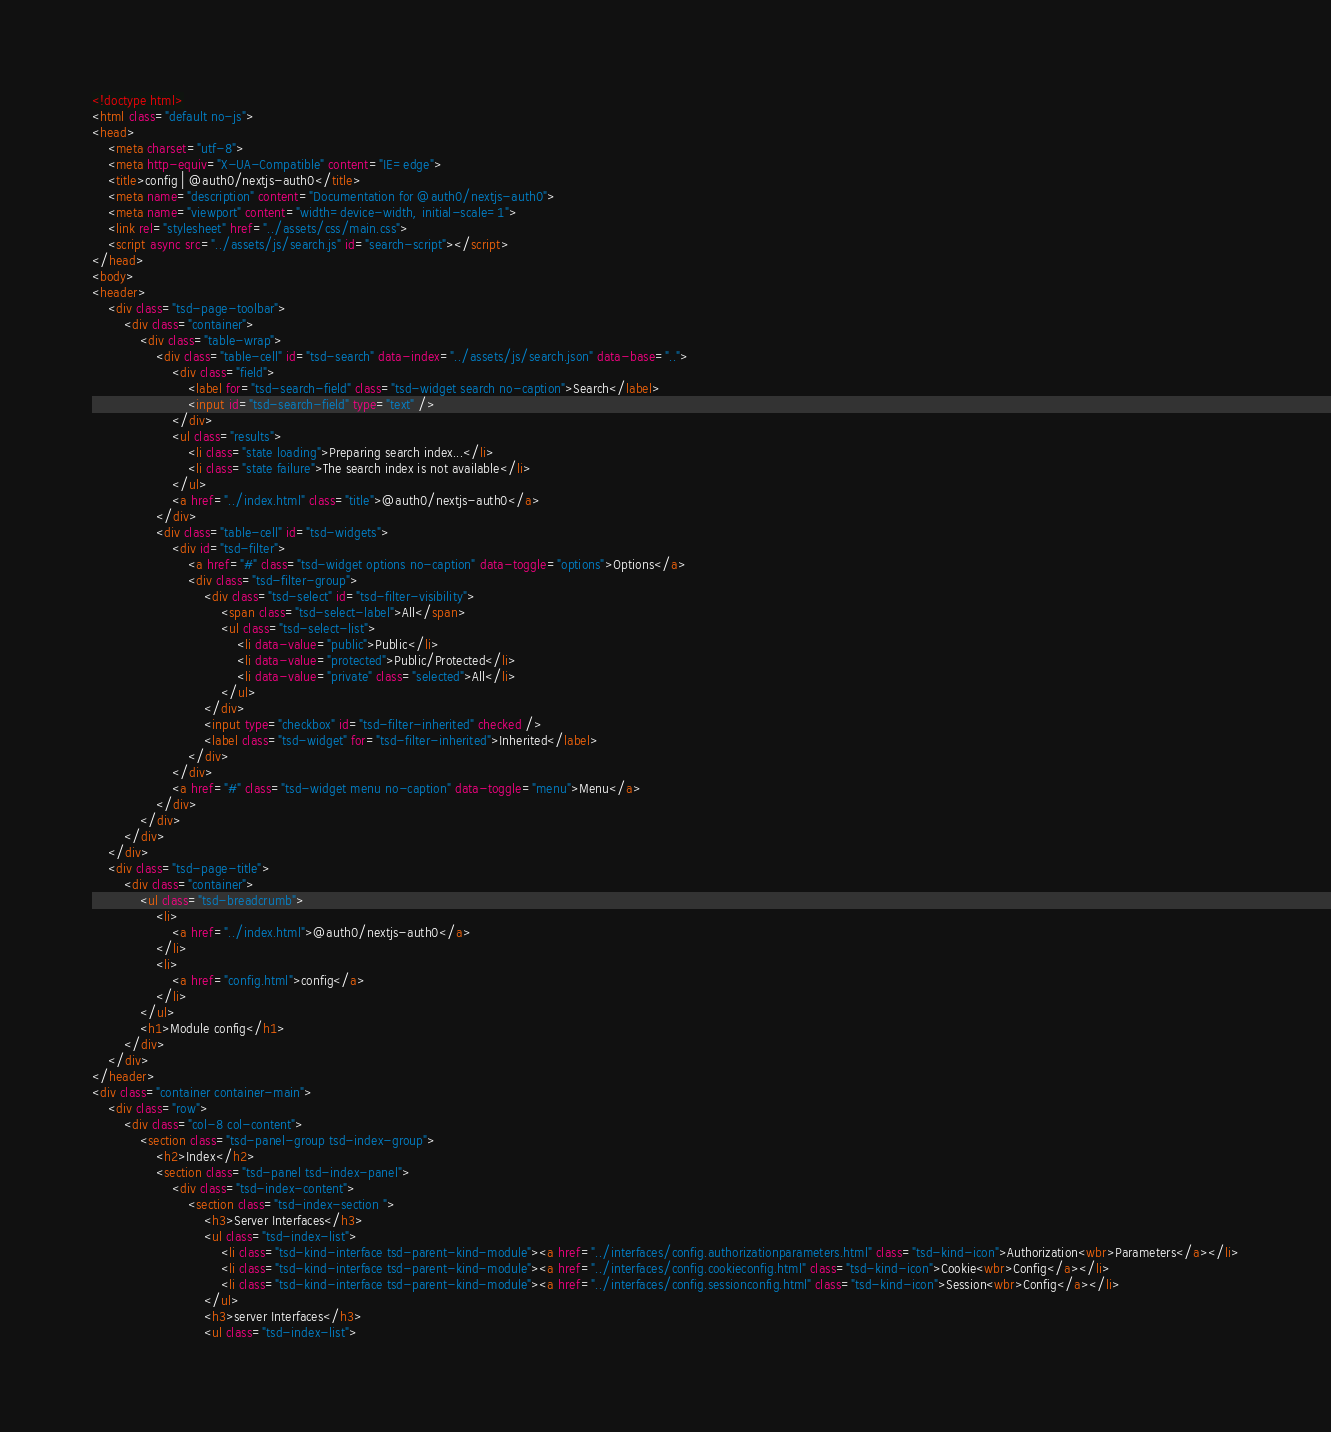<code> <loc_0><loc_0><loc_500><loc_500><_HTML_><!doctype html>
<html class="default no-js">
<head>
	<meta charset="utf-8">
	<meta http-equiv="X-UA-Compatible" content="IE=edge">
	<title>config | @auth0/nextjs-auth0</title>
	<meta name="description" content="Documentation for @auth0/nextjs-auth0">
	<meta name="viewport" content="width=device-width, initial-scale=1">
	<link rel="stylesheet" href="../assets/css/main.css">
	<script async src="../assets/js/search.js" id="search-script"></script>
</head>
<body>
<header>
	<div class="tsd-page-toolbar">
		<div class="container">
			<div class="table-wrap">
				<div class="table-cell" id="tsd-search" data-index="../assets/js/search.json" data-base="..">
					<div class="field">
						<label for="tsd-search-field" class="tsd-widget search no-caption">Search</label>
						<input id="tsd-search-field" type="text" />
					</div>
					<ul class="results">
						<li class="state loading">Preparing search index...</li>
						<li class="state failure">The search index is not available</li>
					</ul>
					<a href="../index.html" class="title">@auth0/nextjs-auth0</a>
				</div>
				<div class="table-cell" id="tsd-widgets">
					<div id="tsd-filter">
						<a href="#" class="tsd-widget options no-caption" data-toggle="options">Options</a>
						<div class="tsd-filter-group">
							<div class="tsd-select" id="tsd-filter-visibility">
								<span class="tsd-select-label">All</span>
								<ul class="tsd-select-list">
									<li data-value="public">Public</li>
									<li data-value="protected">Public/Protected</li>
									<li data-value="private" class="selected">All</li>
								</ul>
							</div>
							<input type="checkbox" id="tsd-filter-inherited" checked />
							<label class="tsd-widget" for="tsd-filter-inherited">Inherited</label>
						</div>
					</div>
					<a href="#" class="tsd-widget menu no-caption" data-toggle="menu">Menu</a>
				</div>
			</div>
		</div>
	</div>
	<div class="tsd-page-title">
		<div class="container">
			<ul class="tsd-breadcrumb">
				<li>
					<a href="../index.html">@auth0/nextjs-auth0</a>
				</li>
				<li>
					<a href="config.html">config</a>
				</li>
			</ul>
			<h1>Module config</h1>
		</div>
	</div>
</header>
<div class="container container-main">
	<div class="row">
		<div class="col-8 col-content">
			<section class="tsd-panel-group tsd-index-group">
				<h2>Index</h2>
				<section class="tsd-panel tsd-index-panel">
					<div class="tsd-index-content">
						<section class="tsd-index-section ">
							<h3>Server Interfaces</h3>
							<ul class="tsd-index-list">
								<li class="tsd-kind-interface tsd-parent-kind-module"><a href="../interfaces/config.authorizationparameters.html" class="tsd-kind-icon">Authorization<wbr>Parameters</a></li>
								<li class="tsd-kind-interface tsd-parent-kind-module"><a href="../interfaces/config.cookieconfig.html" class="tsd-kind-icon">Cookie<wbr>Config</a></li>
								<li class="tsd-kind-interface tsd-parent-kind-module"><a href="../interfaces/config.sessionconfig.html" class="tsd-kind-icon">Session<wbr>Config</a></li>
							</ul>
							<h3>server Interfaces</h3>
							<ul class="tsd-index-list"></code> 